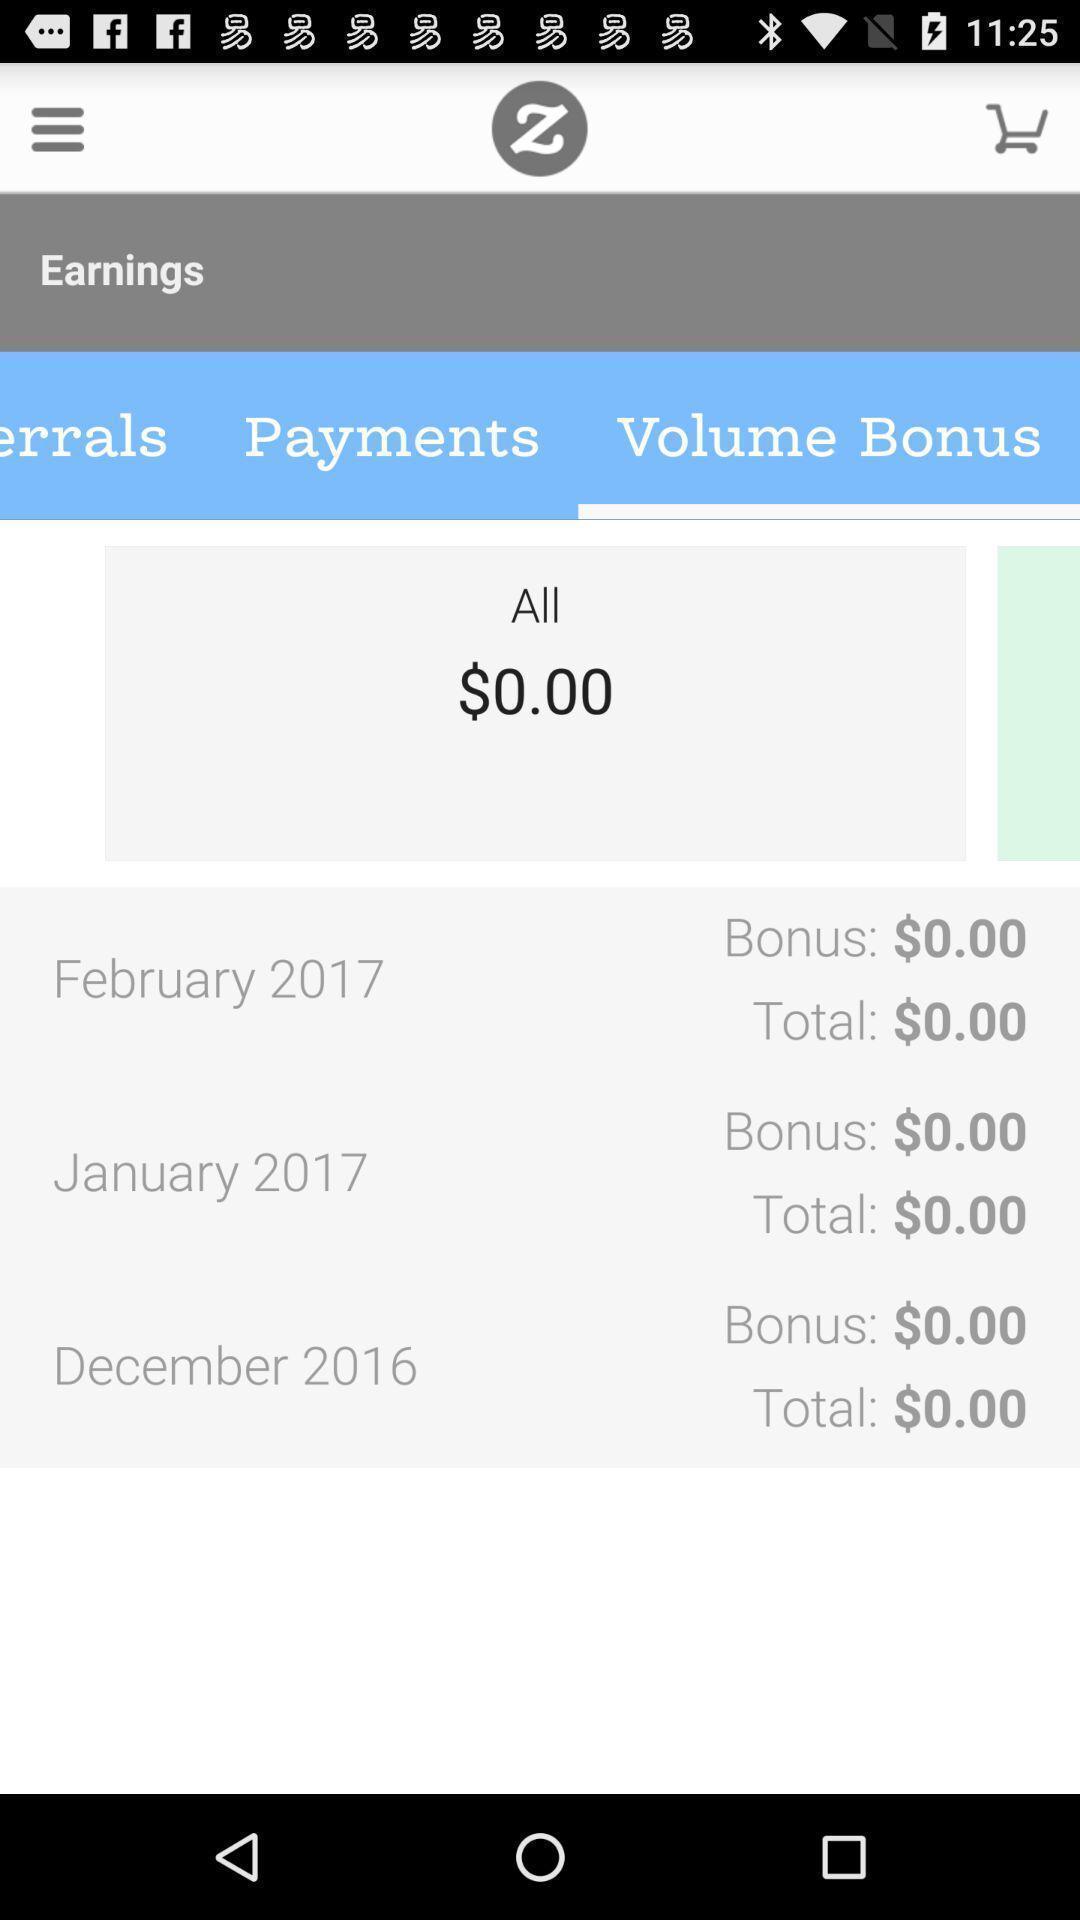Provide a description of this screenshot. Page showing information about market. 